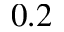Convert formula to latex. <formula><loc_0><loc_0><loc_500><loc_500>0 . 2</formula> 